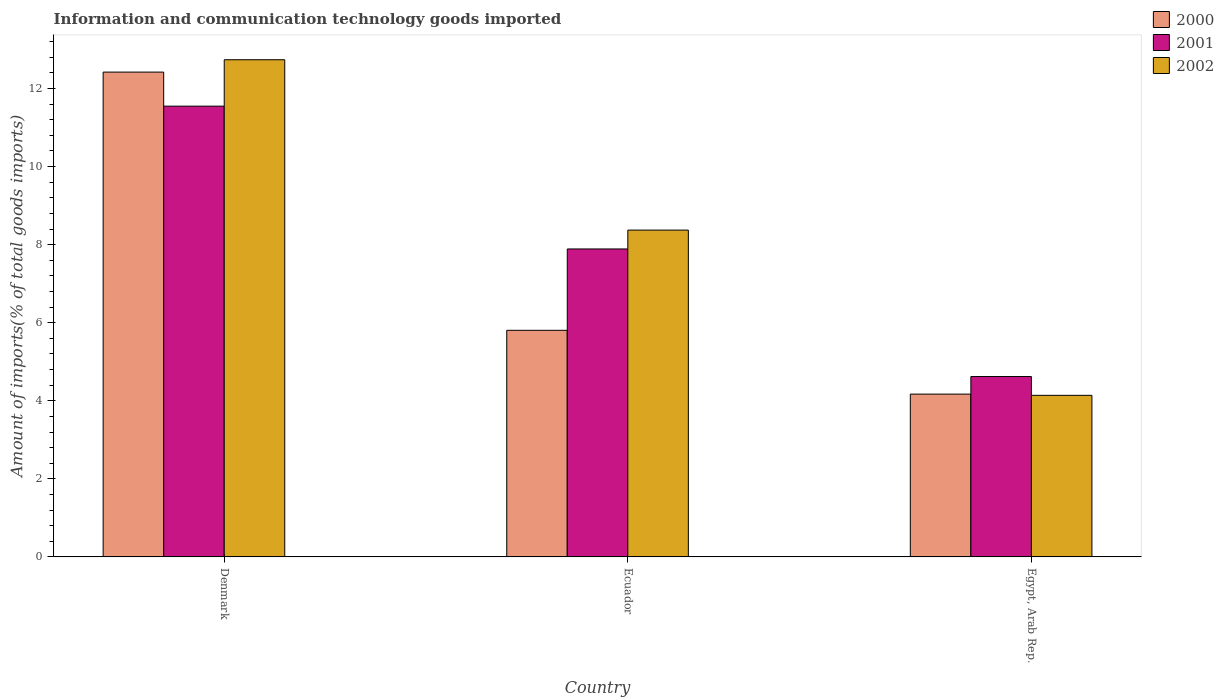How many different coloured bars are there?
Provide a succinct answer. 3. Are the number of bars per tick equal to the number of legend labels?
Give a very brief answer. Yes. Are the number of bars on each tick of the X-axis equal?
Offer a terse response. Yes. How many bars are there on the 3rd tick from the left?
Make the answer very short. 3. How many bars are there on the 1st tick from the right?
Your answer should be compact. 3. What is the label of the 3rd group of bars from the left?
Your response must be concise. Egypt, Arab Rep. In how many cases, is the number of bars for a given country not equal to the number of legend labels?
Your response must be concise. 0. What is the amount of goods imported in 2002 in Ecuador?
Provide a succinct answer. 8.37. Across all countries, what is the maximum amount of goods imported in 2000?
Provide a short and direct response. 12.42. Across all countries, what is the minimum amount of goods imported in 2000?
Your answer should be very brief. 4.17. In which country was the amount of goods imported in 2000 maximum?
Offer a terse response. Denmark. In which country was the amount of goods imported in 2001 minimum?
Offer a terse response. Egypt, Arab Rep. What is the total amount of goods imported in 2002 in the graph?
Provide a succinct answer. 25.25. What is the difference between the amount of goods imported in 2002 in Denmark and that in Egypt, Arab Rep.?
Provide a short and direct response. 8.6. What is the difference between the amount of goods imported in 2001 in Denmark and the amount of goods imported in 2000 in Egypt, Arab Rep.?
Your response must be concise. 7.38. What is the average amount of goods imported in 2000 per country?
Your response must be concise. 7.47. What is the difference between the amount of goods imported of/in 2002 and amount of goods imported of/in 2000 in Denmark?
Give a very brief answer. 0.32. In how many countries, is the amount of goods imported in 2001 greater than 12.4 %?
Keep it short and to the point. 0. What is the ratio of the amount of goods imported in 2000 in Denmark to that in Egypt, Arab Rep.?
Provide a succinct answer. 2.98. Is the amount of goods imported in 2002 in Ecuador less than that in Egypt, Arab Rep.?
Your response must be concise. No. Is the difference between the amount of goods imported in 2002 in Denmark and Ecuador greater than the difference between the amount of goods imported in 2000 in Denmark and Ecuador?
Your response must be concise. No. What is the difference between the highest and the second highest amount of goods imported in 2002?
Your answer should be compact. -4.36. What is the difference between the highest and the lowest amount of goods imported in 2000?
Provide a short and direct response. 8.25. Is the sum of the amount of goods imported in 2000 in Ecuador and Egypt, Arab Rep. greater than the maximum amount of goods imported in 2002 across all countries?
Make the answer very short. No. What does the 2nd bar from the right in Ecuador represents?
Provide a short and direct response. 2001. Is it the case that in every country, the sum of the amount of goods imported in 2000 and amount of goods imported in 2001 is greater than the amount of goods imported in 2002?
Make the answer very short. Yes. How many bars are there?
Provide a succinct answer. 9. Are all the bars in the graph horizontal?
Your answer should be compact. No. What is the difference between two consecutive major ticks on the Y-axis?
Your answer should be compact. 2. Does the graph contain any zero values?
Provide a short and direct response. No. Does the graph contain grids?
Provide a short and direct response. No. How are the legend labels stacked?
Your answer should be compact. Vertical. What is the title of the graph?
Your answer should be very brief. Information and communication technology goods imported. Does "1983" appear as one of the legend labels in the graph?
Provide a short and direct response. No. What is the label or title of the X-axis?
Offer a very short reply. Country. What is the label or title of the Y-axis?
Ensure brevity in your answer.  Amount of imports(% of total goods imports). What is the Amount of imports(% of total goods imports) of 2000 in Denmark?
Provide a short and direct response. 12.42. What is the Amount of imports(% of total goods imports) in 2001 in Denmark?
Offer a terse response. 11.55. What is the Amount of imports(% of total goods imports) in 2002 in Denmark?
Your response must be concise. 12.74. What is the Amount of imports(% of total goods imports) in 2000 in Ecuador?
Ensure brevity in your answer.  5.81. What is the Amount of imports(% of total goods imports) of 2001 in Ecuador?
Provide a succinct answer. 7.89. What is the Amount of imports(% of total goods imports) in 2002 in Ecuador?
Make the answer very short. 8.37. What is the Amount of imports(% of total goods imports) of 2000 in Egypt, Arab Rep.?
Provide a succinct answer. 4.17. What is the Amount of imports(% of total goods imports) in 2001 in Egypt, Arab Rep.?
Your response must be concise. 4.62. What is the Amount of imports(% of total goods imports) in 2002 in Egypt, Arab Rep.?
Offer a very short reply. 4.14. Across all countries, what is the maximum Amount of imports(% of total goods imports) of 2000?
Give a very brief answer. 12.42. Across all countries, what is the maximum Amount of imports(% of total goods imports) of 2001?
Your answer should be compact. 11.55. Across all countries, what is the maximum Amount of imports(% of total goods imports) in 2002?
Your answer should be compact. 12.74. Across all countries, what is the minimum Amount of imports(% of total goods imports) of 2000?
Provide a short and direct response. 4.17. Across all countries, what is the minimum Amount of imports(% of total goods imports) in 2001?
Ensure brevity in your answer.  4.62. Across all countries, what is the minimum Amount of imports(% of total goods imports) in 2002?
Provide a succinct answer. 4.14. What is the total Amount of imports(% of total goods imports) in 2000 in the graph?
Offer a very short reply. 22.4. What is the total Amount of imports(% of total goods imports) in 2001 in the graph?
Offer a terse response. 24.06. What is the total Amount of imports(% of total goods imports) in 2002 in the graph?
Offer a terse response. 25.25. What is the difference between the Amount of imports(% of total goods imports) in 2000 in Denmark and that in Ecuador?
Give a very brief answer. 6.62. What is the difference between the Amount of imports(% of total goods imports) of 2001 in Denmark and that in Ecuador?
Provide a short and direct response. 3.66. What is the difference between the Amount of imports(% of total goods imports) in 2002 in Denmark and that in Ecuador?
Keep it short and to the point. 4.36. What is the difference between the Amount of imports(% of total goods imports) of 2000 in Denmark and that in Egypt, Arab Rep.?
Offer a very short reply. 8.25. What is the difference between the Amount of imports(% of total goods imports) of 2001 in Denmark and that in Egypt, Arab Rep.?
Make the answer very short. 6.93. What is the difference between the Amount of imports(% of total goods imports) in 2002 in Denmark and that in Egypt, Arab Rep.?
Make the answer very short. 8.6. What is the difference between the Amount of imports(% of total goods imports) in 2000 in Ecuador and that in Egypt, Arab Rep.?
Ensure brevity in your answer.  1.63. What is the difference between the Amount of imports(% of total goods imports) of 2001 in Ecuador and that in Egypt, Arab Rep.?
Offer a terse response. 3.27. What is the difference between the Amount of imports(% of total goods imports) in 2002 in Ecuador and that in Egypt, Arab Rep.?
Your answer should be compact. 4.23. What is the difference between the Amount of imports(% of total goods imports) of 2000 in Denmark and the Amount of imports(% of total goods imports) of 2001 in Ecuador?
Keep it short and to the point. 4.53. What is the difference between the Amount of imports(% of total goods imports) in 2000 in Denmark and the Amount of imports(% of total goods imports) in 2002 in Ecuador?
Give a very brief answer. 4.05. What is the difference between the Amount of imports(% of total goods imports) of 2001 in Denmark and the Amount of imports(% of total goods imports) of 2002 in Ecuador?
Give a very brief answer. 3.18. What is the difference between the Amount of imports(% of total goods imports) in 2000 in Denmark and the Amount of imports(% of total goods imports) in 2001 in Egypt, Arab Rep.?
Your answer should be compact. 7.8. What is the difference between the Amount of imports(% of total goods imports) in 2000 in Denmark and the Amount of imports(% of total goods imports) in 2002 in Egypt, Arab Rep.?
Keep it short and to the point. 8.28. What is the difference between the Amount of imports(% of total goods imports) of 2001 in Denmark and the Amount of imports(% of total goods imports) of 2002 in Egypt, Arab Rep.?
Offer a terse response. 7.41. What is the difference between the Amount of imports(% of total goods imports) of 2000 in Ecuador and the Amount of imports(% of total goods imports) of 2001 in Egypt, Arab Rep.?
Make the answer very short. 1.18. What is the difference between the Amount of imports(% of total goods imports) in 2000 in Ecuador and the Amount of imports(% of total goods imports) in 2002 in Egypt, Arab Rep.?
Your answer should be very brief. 1.67. What is the difference between the Amount of imports(% of total goods imports) of 2001 in Ecuador and the Amount of imports(% of total goods imports) of 2002 in Egypt, Arab Rep.?
Give a very brief answer. 3.75. What is the average Amount of imports(% of total goods imports) in 2000 per country?
Give a very brief answer. 7.47. What is the average Amount of imports(% of total goods imports) of 2001 per country?
Make the answer very short. 8.02. What is the average Amount of imports(% of total goods imports) in 2002 per country?
Offer a terse response. 8.42. What is the difference between the Amount of imports(% of total goods imports) of 2000 and Amount of imports(% of total goods imports) of 2001 in Denmark?
Your answer should be very brief. 0.87. What is the difference between the Amount of imports(% of total goods imports) in 2000 and Amount of imports(% of total goods imports) in 2002 in Denmark?
Provide a succinct answer. -0.32. What is the difference between the Amount of imports(% of total goods imports) of 2001 and Amount of imports(% of total goods imports) of 2002 in Denmark?
Offer a terse response. -1.19. What is the difference between the Amount of imports(% of total goods imports) of 2000 and Amount of imports(% of total goods imports) of 2001 in Ecuador?
Provide a succinct answer. -2.08. What is the difference between the Amount of imports(% of total goods imports) in 2000 and Amount of imports(% of total goods imports) in 2002 in Ecuador?
Your answer should be very brief. -2.57. What is the difference between the Amount of imports(% of total goods imports) in 2001 and Amount of imports(% of total goods imports) in 2002 in Ecuador?
Your response must be concise. -0.48. What is the difference between the Amount of imports(% of total goods imports) in 2000 and Amount of imports(% of total goods imports) in 2001 in Egypt, Arab Rep.?
Give a very brief answer. -0.45. What is the difference between the Amount of imports(% of total goods imports) in 2000 and Amount of imports(% of total goods imports) in 2002 in Egypt, Arab Rep.?
Offer a terse response. 0.03. What is the difference between the Amount of imports(% of total goods imports) of 2001 and Amount of imports(% of total goods imports) of 2002 in Egypt, Arab Rep.?
Offer a very short reply. 0.48. What is the ratio of the Amount of imports(% of total goods imports) of 2000 in Denmark to that in Ecuador?
Provide a succinct answer. 2.14. What is the ratio of the Amount of imports(% of total goods imports) in 2001 in Denmark to that in Ecuador?
Keep it short and to the point. 1.46. What is the ratio of the Amount of imports(% of total goods imports) of 2002 in Denmark to that in Ecuador?
Your answer should be compact. 1.52. What is the ratio of the Amount of imports(% of total goods imports) in 2000 in Denmark to that in Egypt, Arab Rep.?
Provide a succinct answer. 2.98. What is the ratio of the Amount of imports(% of total goods imports) in 2001 in Denmark to that in Egypt, Arab Rep.?
Ensure brevity in your answer.  2.5. What is the ratio of the Amount of imports(% of total goods imports) in 2002 in Denmark to that in Egypt, Arab Rep.?
Ensure brevity in your answer.  3.08. What is the ratio of the Amount of imports(% of total goods imports) of 2000 in Ecuador to that in Egypt, Arab Rep.?
Offer a very short reply. 1.39. What is the ratio of the Amount of imports(% of total goods imports) of 2001 in Ecuador to that in Egypt, Arab Rep.?
Offer a terse response. 1.71. What is the ratio of the Amount of imports(% of total goods imports) of 2002 in Ecuador to that in Egypt, Arab Rep.?
Your answer should be compact. 2.02. What is the difference between the highest and the second highest Amount of imports(% of total goods imports) of 2000?
Keep it short and to the point. 6.62. What is the difference between the highest and the second highest Amount of imports(% of total goods imports) in 2001?
Provide a succinct answer. 3.66. What is the difference between the highest and the second highest Amount of imports(% of total goods imports) in 2002?
Give a very brief answer. 4.36. What is the difference between the highest and the lowest Amount of imports(% of total goods imports) in 2000?
Offer a terse response. 8.25. What is the difference between the highest and the lowest Amount of imports(% of total goods imports) of 2001?
Offer a very short reply. 6.93. What is the difference between the highest and the lowest Amount of imports(% of total goods imports) in 2002?
Give a very brief answer. 8.6. 